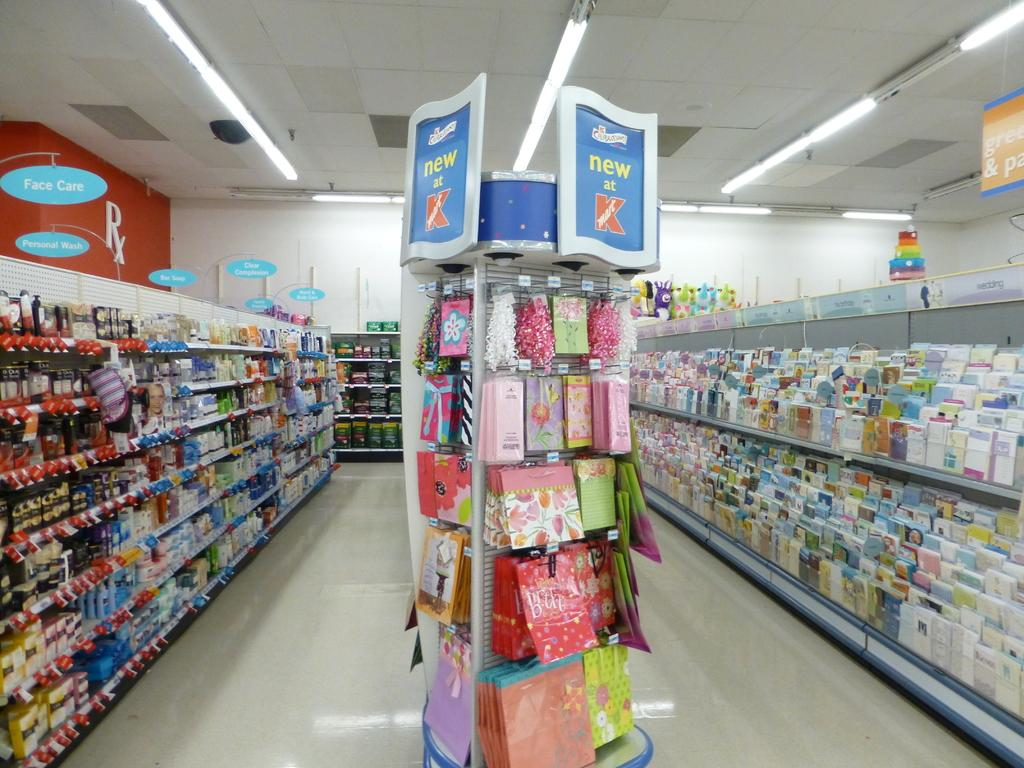<image>
Render a clear and concise summary of the photo. A sign at the end of the aisle advertises what is new at Kmart. 